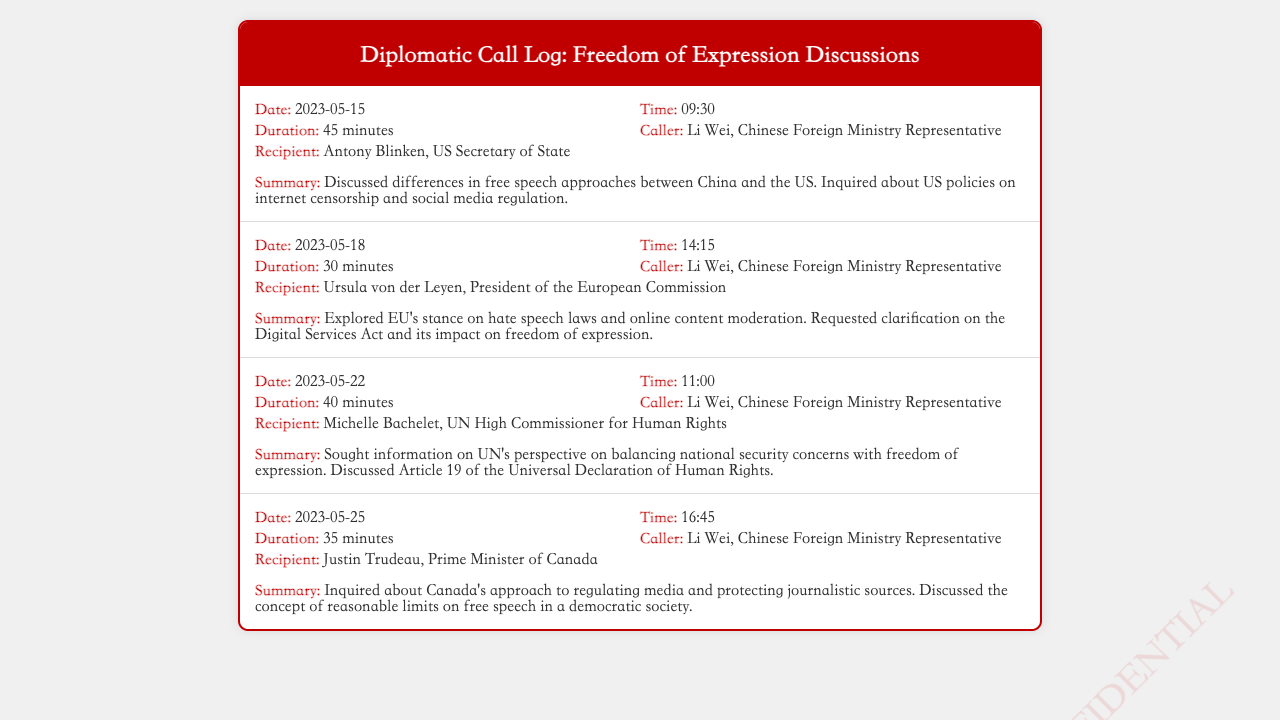What is the duration of the call on May 15? The duration of the call on May 15 is stated in the record as 45 minutes.
Answer: 45 minutes Who is the recipient of the call on May 18? The recipient of the call on May 18 is identified in the record as Ursula von der Leyen, President of the European Commission.
Answer: Ursula von der Leyen What topic was discussed in the call with Michelle Bachelet? The summary for the call with Michelle Bachelet indicates that they discussed the UN's perspective on balancing national security concerns with freedom of expression.
Answer: Balancing national security concerns with freedom of expression What is the common caller in all records? The common caller in all records is mentioned as Li Wei, Chinese Foreign Ministry Representative.
Answer: Li Wei, Chinese Foreign Ministry Representative How many minutes did the call with Justin Trudeau last? The duration of the call with Justin Trudeau is reported as 35 minutes.
Answer: 35 minutes Which Article of the Universal Declaration of Human Rights was discussed? The record notes that Article 19 of the Universal Declaration of Human Rights was discussed in the call with Michelle Bachelet.
Answer: Article 19 What was the primary focus of the discussions on May 25? The primary focus of the discussions on May 25 was about Canada’s approach to regulating media and protecting journalistic sources.
Answer: Canada’s approach to regulating media and protecting journalistic sources What is the date of the first call listed in the log? The date of the first call listed in the log is presented as May 15, 2023.
Answer: May 15, 2023 What is the title of the caller in the fourth call? The title of the caller in the fourth call is labeled as Chinese Foreign Ministry Representative.
Answer: Chinese Foreign Ministry Representative 